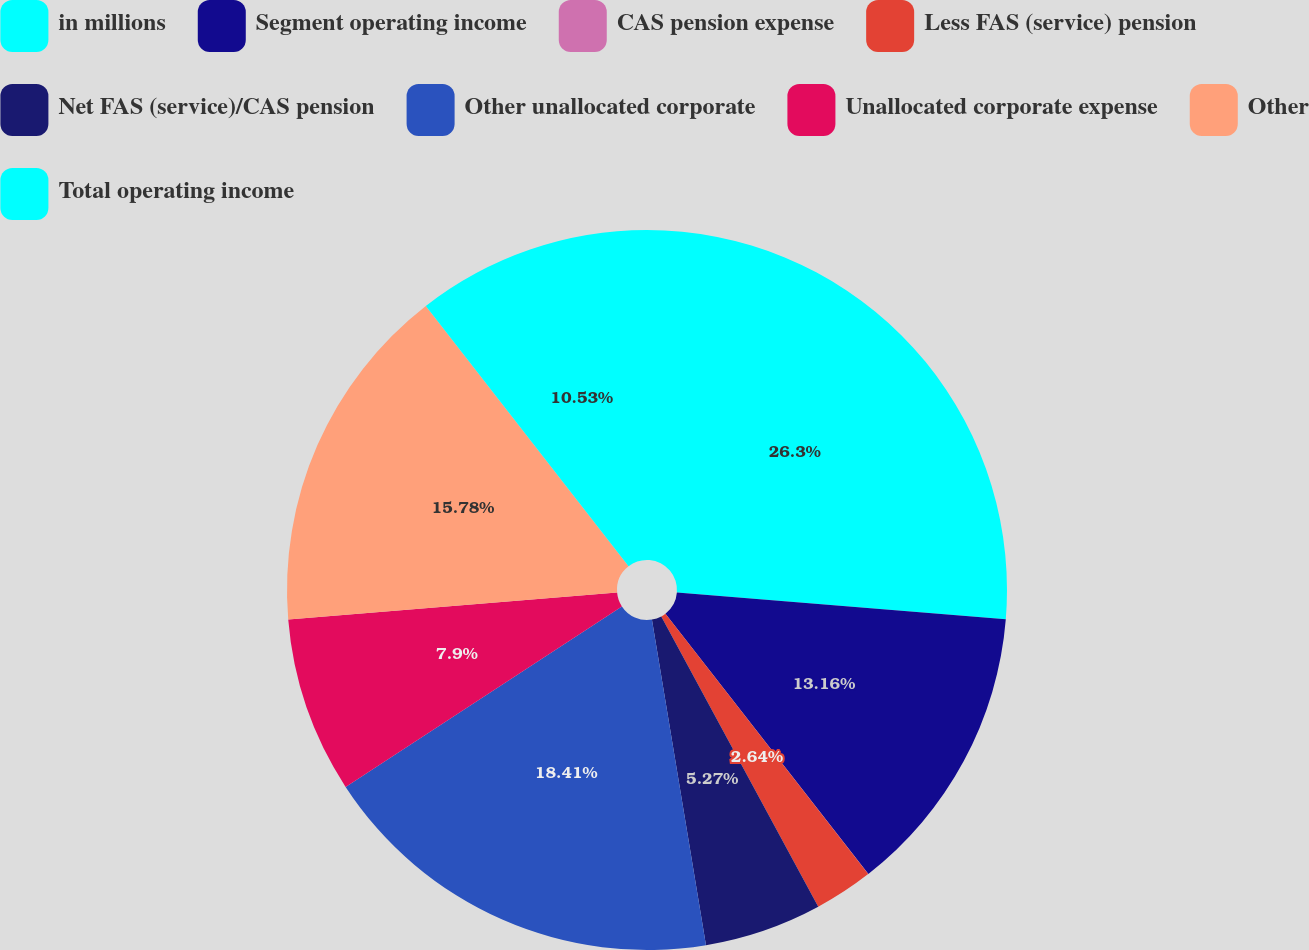Convert chart to OTSL. <chart><loc_0><loc_0><loc_500><loc_500><pie_chart><fcel>in millions<fcel>Segment operating income<fcel>CAS pension expense<fcel>Less FAS (service) pension<fcel>Net FAS (service)/CAS pension<fcel>Other unallocated corporate<fcel>Unallocated corporate expense<fcel>Other<fcel>Total operating income<nl><fcel>26.3%<fcel>13.16%<fcel>0.01%<fcel>2.64%<fcel>5.27%<fcel>18.41%<fcel>7.9%<fcel>15.78%<fcel>10.53%<nl></chart> 